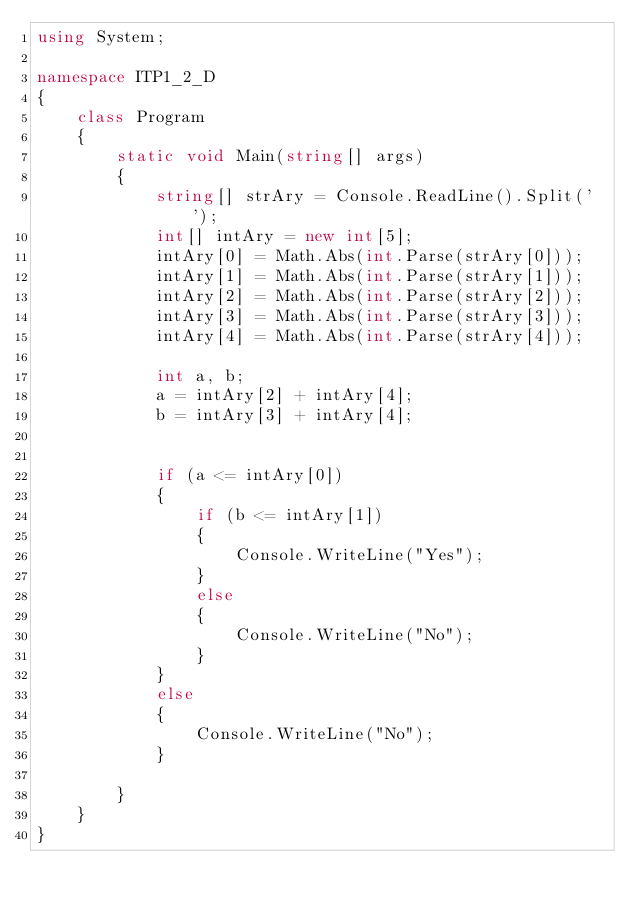Convert code to text. <code><loc_0><loc_0><loc_500><loc_500><_C#_>using System;

namespace ITP1_2_D
{
    class Program
    {
        static void Main(string[] args)
        {
            string[] strAry = Console.ReadLine().Split(' ');
            int[] intAry = new int[5];
            intAry[0] = Math.Abs(int.Parse(strAry[0]));
            intAry[1] = Math.Abs(int.Parse(strAry[1]));
            intAry[2] = Math.Abs(int.Parse(strAry[2]));
            intAry[3] = Math.Abs(int.Parse(strAry[3]));
            intAry[4] = Math.Abs(int.Parse(strAry[4]));

            int a, b;
            a = intAry[2] + intAry[4];
            b = intAry[3] + intAry[4];


            if (a <= intAry[0])
            {
                if (b <= intAry[1])
                {
                    Console.WriteLine("Yes");
                }
                else
                {
                    Console.WriteLine("No");
                }
            }
            else
            {
                Console.WriteLine("No");
            }

        }
    }
}</code> 